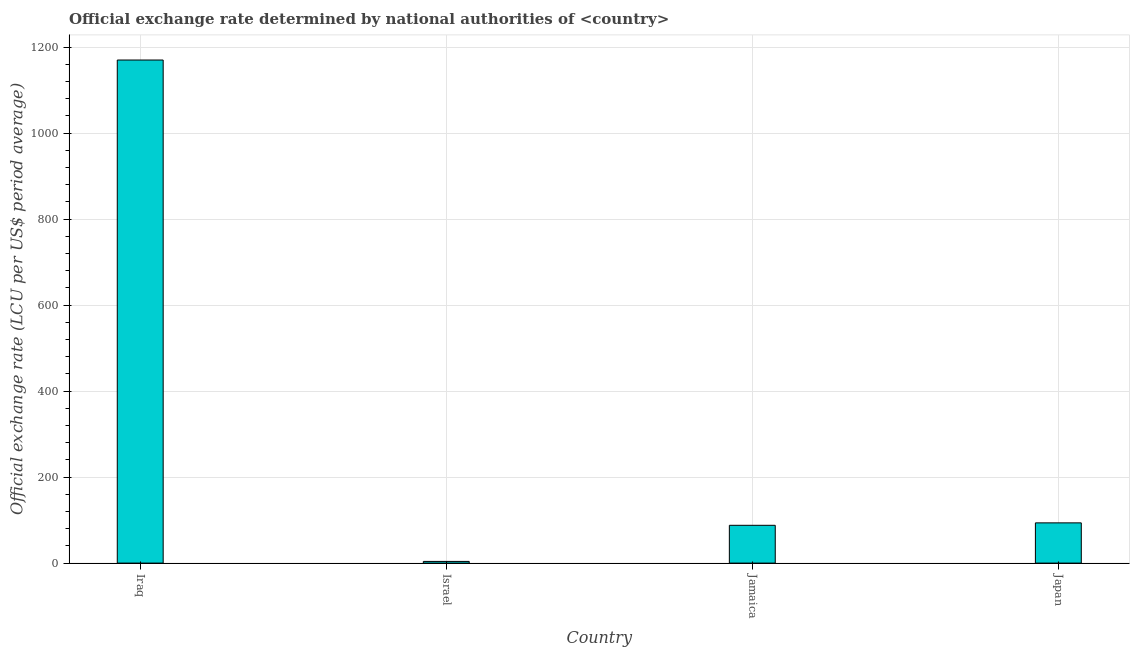What is the title of the graph?
Your response must be concise. Official exchange rate determined by national authorities of <country>. What is the label or title of the X-axis?
Keep it short and to the point. Country. What is the label or title of the Y-axis?
Ensure brevity in your answer.  Official exchange rate (LCU per US$ period average). What is the official exchange rate in Jamaica?
Provide a short and direct response. 87.89. Across all countries, what is the maximum official exchange rate?
Ensure brevity in your answer.  1170. Across all countries, what is the minimum official exchange rate?
Offer a very short reply. 3.93. In which country was the official exchange rate maximum?
Provide a succinct answer. Iraq. In which country was the official exchange rate minimum?
Keep it short and to the point. Israel. What is the sum of the official exchange rate?
Your answer should be very brief. 1355.4. What is the difference between the official exchange rate in Iraq and Japan?
Provide a succinct answer. 1076.43. What is the average official exchange rate per country?
Provide a short and direct response. 338.85. What is the median official exchange rate?
Give a very brief answer. 90.73. In how many countries, is the official exchange rate greater than 1000 ?
Offer a very short reply. 1. What is the ratio of the official exchange rate in Israel to that in Jamaica?
Give a very brief answer. 0.04. Is the official exchange rate in Iraq less than that in Israel?
Keep it short and to the point. No. Is the difference between the official exchange rate in Israel and Japan greater than the difference between any two countries?
Provide a succinct answer. No. What is the difference between the highest and the second highest official exchange rate?
Offer a very short reply. 1076.43. Is the sum of the official exchange rate in Iraq and Japan greater than the maximum official exchange rate across all countries?
Offer a very short reply. Yes. What is the difference between the highest and the lowest official exchange rate?
Make the answer very short. 1166.07. Are all the bars in the graph horizontal?
Offer a terse response. No. How many countries are there in the graph?
Keep it short and to the point. 4. What is the difference between two consecutive major ticks on the Y-axis?
Ensure brevity in your answer.  200. Are the values on the major ticks of Y-axis written in scientific E-notation?
Offer a terse response. No. What is the Official exchange rate (LCU per US$ period average) in Iraq?
Your response must be concise. 1170. What is the Official exchange rate (LCU per US$ period average) in Israel?
Offer a very short reply. 3.93. What is the Official exchange rate (LCU per US$ period average) in Jamaica?
Make the answer very short. 87.89. What is the Official exchange rate (LCU per US$ period average) of Japan?
Your answer should be compact. 93.57. What is the difference between the Official exchange rate (LCU per US$ period average) in Iraq and Israel?
Your response must be concise. 1166.07. What is the difference between the Official exchange rate (LCU per US$ period average) in Iraq and Jamaica?
Your answer should be compact. 1082.11. What is the difference between the Official exchange rate (LCU per US$ period average) in Iraq and Japan?
Keep it short and to the point. 1076.43. What is the difference between the Official exchange rate (LCU per US$ period average) in Israel and Jamaica?
Make the answer very short. -83.96. What is the difference between the Official exchange rate (LCU per US$ period average) in Israel and Japan?
Make the answer very short. -89.64. What is the difference between the Official exchange rate (LCU per US$ period average) in Jamaica and Japan?
Offer a very short reply. -5.68. What is the ratio of the Official exchange rate (LCU per US$ period average) in Iraq to that in Israel?
Your response must be concise. 297.53. What is the ratio of the Official exchange rate (LCU per US$ period average) in Iraq to that in Jamaica?
Offer a very short reply. 13.31. What is the ratio of the Official exchange rate (LCU per US$ period average) in Iraq to that in Japan?
Make the answer very short. 12.5. What is the ratio of the Official exchange rate (LCU per US$ period average) in Israel to that in Jamaica?
Make the answer very short. 0.04. What is the ratio of the Official exchange rate (LCU per US$ period average) in Israel to that in Japan?
Provide a succinct answer. 0.04. What is the ratio of the Official exchange rate (LCU per US$ period average) in Jamaica to that in Japan?
Provide a short and direct response. 0.94. 